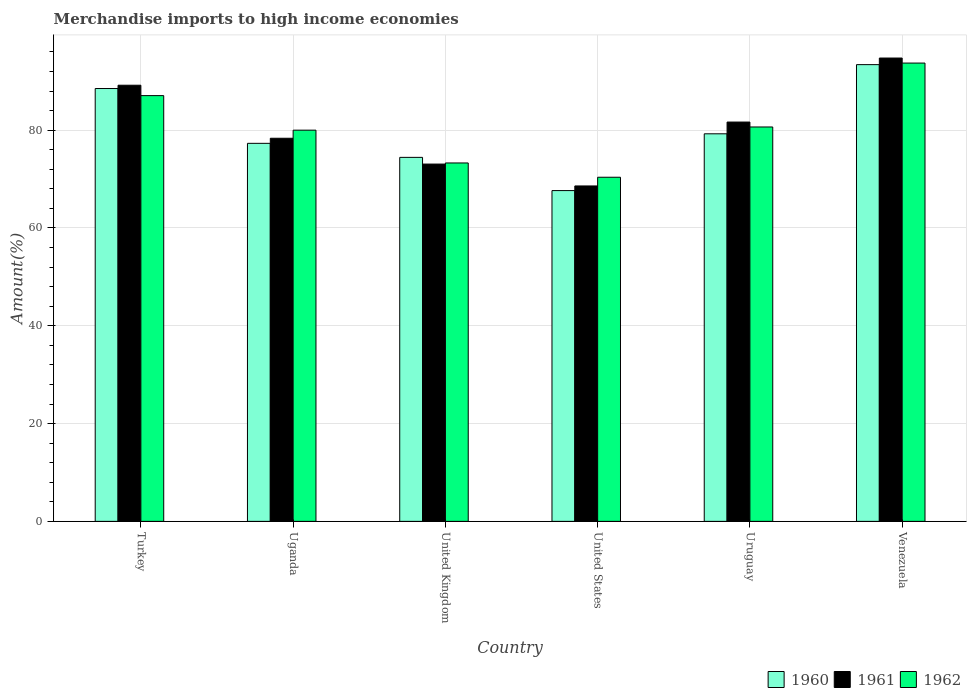Are the number of bars per tick equal to the number of legend labels?
Offer a terse response. Yes. How many bars are there on the 3rd tick from the right?
Ensure brevity in your answer.  3. What is the label of the 6th group of bars from the left?
Offer a terse response. Venezuela. In how many cases, is the number of bars for a given country not equal to the number of legend labels?
Make the answer very short. 0. What is the percentage of amount earned from merchandise imports in 1961 in United States?
Your response must be concise. 68.59. Across all countries, what is the maximum percentage of amount earned from merchandise imports in 1962?
Provide a short and direct response. 93.72. Across all countries, what is the minimum percentage of amount earned from merchandise imports in 1961?
Offer a very short reply. 68.59. In which country was the percentage of amount earned from merchandise imports in 1960 maximum?
Provide a succinct answer. Venezuela. In which country was the percentage of amount earned from merchandise imports in 1961 minimum?
Your response must be concise. United States. What is the total percentage of amount earned from merchandise imports in 1962 in the graph?
Keep it short and to the point. 485.11. What is the difference between the percentage of amount earned from merchandise imports in 1962 in United States and that in Venezuela?
Give a very brief answer. -23.35. What is the difference between the percentage of amount earned from merchandise imports in 1962 in Venezuela and the percentage of amount earned from merchandise imports in 1961 in Uganda?
Give a very brief answer. 15.38. What is the average percentage of amount earned from merchandise imports in 1962 per country?
Offer a terse response. 80.85. What is the difference between the percentage of amount earned from merchandise imports of/in 1961 and percentage of amount earned from merchandise imports of/in 1962 in Uganda?
Your answer should be compact. -1.65. In how many countries, is the percentage of amount earned from merchandise imports in 1960 greater than 88 %?
Your answer should be very brief. 2. What is the ratio of the percentage of amount earned from merchandise imports in 1961 in Turkey to that in United States?
Provide a short and direct response. 1.3. Is the percentage of amount earned from merchandise imports in 1961 in Turkey less than that in United States?
Provide a succinct answer. No. What is the difference between the highest and the second highest percentage of amount earned from merchandise imports in 1962?
Ensure brevity in your answer.  -13.07. What is the difference between the highest and the lowest percentage of amount earned from merchandise imports in 1962?
Ensure brevity in your answer.  23.35. Are all the bars in the graph horizontal?
Offer a very short reply. No. How many countries are there in the graph?
Your answer should be compact. 6. Are the values on the major ticks of Y-axis written in scientific E-notation?
Ensure brevity in your answer.  No. Does the graph contain grids?
Your answer should be compact. Yes. Where does the legend appear in the graph?
Your answer should be very brief. Bottom right. What is the title of the graph?
Offer a very short reply. Merchandise imports to high income economies. Does "2010" appear as one of the legend labels in the graph?
Give a very brief answer. No. What is the label or title of the X-axis?
Your answer should be compact. Country. What is the label or title of the Y-axis?
Keep it short and to the point. Amount(%). What is the Amount(%) of 1960 in Turkey?
Offer a very short reply. 88.52. What is the Amount(%) in 1961 in Turkey?
Give a very brief answer. 89.19. What is the Amount(%) of 1962 in Turkey?
Keep it short and to the point. 87.07. What is the Amount(%) in 1960 in Uganda?
Your answer should be very brief. 77.31. What is the Amount(%) of 1961 in Uganda?
Provide a short and direct response. 78.35. What is the Amount(%) of 1960 in United Kingdom?
Offer a terse response. 74.44. What is the Amount(%) of 1961 in United Kingdom?
Your answer should be very brief. 73.07. What is the Amount(%) of 1962 in United Kingdom?
Your answer should be compact. 73.3. What is the Amount(%) of 1960 in United States?
Provide a short and direct response. 67.65. What is the Amount(%) in 1961 in United States?
Provide a succinct answer. 68.59. What is the Amount(%) of 1962 in United States?
Your answer should be very brief. 70.37. What is the Amount(%) in 1960 in Uruguay?
Offer a terse response. 79.26. What is the Amount(%) in 1961 in Uruguay?
Provide a succinct answer. 81.66. What is the Amount(%) in 1962 in Uruguay?
Make the answer very short. 80.65. What is the Amount(%) of 1960 in Venezuela?
Keep it short and to the point. 93.4. What is the Amount(%) in 1961 in Venezuela?
Provide a short and direct response. 94.75. What is the Amount(%) in 1962 in Venezuela?
Your answer should be compact. 93.72. Across all countries, what is the maximum Amount(%) in 1960?
Offer a very short reply. 93.4. Across all countries, what is the maximum Amount(%) in 1961?
Offer a terse response. 94.75. Across all countries, what is the maximum Amount(%) of 1962?
Offer a terse response. 93.72. Across all countries, what is the minimum Amount(%) of 1960?
Make the answer very short. 67.65. Across all countries, what is the minimum Amount(%) of 1961?
Provide a succinct answer. 68.59. Across all countries, what is the minimum Amount(%) of 1962?
Make the answer very short. 70.37. What is the total Amount(%) of 1960 in the graph?
Offer a terse response. 480.57. What is the total Amount(%) in 1961 in the graph?
Provide a short and direct response. 485.61. What is the total Amount(%) in 1962 in the graph?
Keep it short and to the point. 485.11. What is the difference between the Amount(%) of 1960 in Turkey and that in Uganda?
Ensure brevity in your answer.  11.21. What is the difference between the Amount(%) of 1961 in Turkey and that in Uganda?
Ensure brevity in your answer.  10.84. What is the difference between the Amount(%) of 1962 in Turkey and that in Uganda?
Your answer should be compact. 7.07. What is the difference between the Amount(%) in 1960 in Turkey and that in United Kingdom?
Provide a succinct answer. 14.08. What is the difference between the Amount(%) of 1961 in Turkey and that in United Kingdom?
Make the answer very short. 16.12. What is the difference between the Amount(%) in 1962 in Turkey and that in United Kingdom?
Make the answer very short. 13.77. What is the difference between the Amount(%) of 1960 in Turkey and that in United States?
Your response must be concise. 20.87. What is the difference between the Amount(%) in 1961 in Turkey and that in United States?
Give a very brief answer. 20.6. What is the difference between the Amount(%) of 1962 in Turkey and that in United States?
Ensure brevity in your answer.  16.69. What is the difference between the Amount(%) of 1960 in Turkey and that in Uruguay?
Offer a terse response. 9.26. What is the difference between the Amount(%) in 1961 in Turkey and that in Uruguay?
Offer a very short reply. 7.53. What is the difference between the Amount(%) of 1962 in Turkey and that in Uruguay?
Provide a succinct answer. 6.41. What is the difference between the Amount(%) of 1960 in Turkey and that in Venezuela?
Keep it short and to the point. -4.89. What is the difference between the Amount(%) in 1961 in Turkey and that in Venezuela?
Ensure brevity in your answer.  -5.56. What is the difference between the Amount(%) of 1962 in Turkey and that in Venezuela?
Make the answer very short. -6.66. What is the difference between the Amount(%) of 1960 in Uganda and that in United Kingdom?
Offer a terse response. 2.87. What is the difference between the Amount(%) of 1961 in Uganda and that in United Kingdom?
Ensure brevity in your answer.  5.28. What is the difference between the Amount(%) in 1962 in Uganda and that in United Kingdom?
Make the answer very short. 6.7. What is the difference between the Amount(%) in 1960 in Uganda and that in United States?
Your response must be concise. 9.66. What is the difference between the Amount(%) in 1961 in Uganda and that in United States?
Ensure brevity in your answer.  9.75. What is the difference between the Amount(%) of 1962 in Uganda and that in United States?
Your answer should be very brief. 9.63. What is the difference between the Amount(%) of 1960 in Uganda and that in Uruguay?
Give a very brief answer. -1.95. What is the difference between the Amount(%) in 1961 in Uganda and that in Uruguay?
Your response must be concise. -3.32. What is the difference between the Amount(%) in 1962 in Uganda and that in Uruguay?
Provide a succinct answer. -0.65. What is the difference between the Amount(%) of 1960 in Uganda and that in Venezuela?
Your answer should be very brief. -16.1. What is the difference between the Amount(%) of 1961 in Uganda and that in Venezuela?
Keep it short and to the point. -16.41. What is the difference between the Amount(%) of 1962 in Uganda and that in Venezuela?
Your response must be concise. -13.72. What is the difference between the Amount(%) in 1960 in United Kingdom and that in United States?
Provide a succinct answer. 6.79. What is the difference between the Amount(%) of 1961 in United Kingdom and that in United States?
Offer a very short reply. 4.48. What is the difference between the Amount(%) of 1962 in United Kingdom and that in United States?
Ensure brevity in your answer.  2.92. What is the difference between the Amount(%) of 1960 in United Kingdom and that in Uruguay?
Offer a terse response. -4.82. What is the difference between the Amount(%) in 1961 in United Kingdom and that in Uruguay?
Your answer should be very brief. -8.59. What is the difference between the Amount(%) in 1962 in United Kingdom and that in Uruguay?
Keep it short and to the point. -7.36. What is the difference between the Amount(%) of 1960 in United Kingdom and that in Venezuela?
Your answer should be compact. -18.97. What is the difference between the Amount(%) in 1961 in United Kingdom and that in Venezuela?
Provide a short and direct response. -21.68. What is the difference between the Amount(%) of 1962 in United Kingdom and that in Venezuela?
Offer a very short reply. -20.43. What is the difference between the Amount(%) of 1960 in United States and that in Uruguay?
Your answer should be very brief. -11.61. What is the difference between the Amount(%) in 1961 in United States and that in Uruguay?
Make the answer very short. -13.07. What is the difference between the Amount(%) in 1962 in United States and that in Uruguay?
Offer a terse response. -10.28. What is the difference between the Amount(%) in 1960 in United States and that in Venezuela?
Keep it short and to the point. -25.76. What is the difference between the Amount(%) of 1961 in United States and that in Venezuela?
Make the answer very short. -26.16. What is the difference between the Amount(%) in 1962 in United States and that in Venezuela?
Offer a very short reply. -23.35. What is the difference between the Amount(%) of 1960 in Uruguay and that in Venezuela?
Keep it short and to the point. -14.15. What is the difference between the Amount(%) of 1961 in Uruguay and that in Venezuela?
Offer a terse response. -13.09. What is the difference between the Amount(%) in 1962 in Uruguay and that in Venezuela?
Your answer should be very brief. -13.07. What is the difference between the Amount(%) in 1960 in Turkey and the Amount(%) in 1961 in Uganda?
Offer a terse response. 10.17. What is the difference between the Amount(%) in 1960 in Turkey and the Amount(%) in 1962 in Uganda?
Ensure brevity in your answer.  8.52. What is the difference between the Amount(%) in 1961 in Turkey and the Amount(%) in 1962 in Uganda?
Keep it short and to the point. 9.19. What is the difference between the Amount(%) in 1960 in Turkey and the Amount(%) in 1961 in United Kingdom?
Make the answer very short. 15.45. What is the difference between the Amount(%) in 1960 in Turkey and the Amount(%) in 1962 in United Kingdom?
Provide a short and direct response. 15.22. What is the difference between the Amount(%) in 1961 in Turkey and the Amount(%) in 1962 in United Kingdom?
Your answer should be compact. 15.89. What is the difference between the Amount(%) of 1960 in Turkey and the Amount(%) of 1961 in United States?
Ensure brevity in your answer.  19.93. What is the difference between the Amount(%) of 1960 in Turkey and the Amount(%) of 1962 in United States?
Give a very brief answer. 18.14. What is the difference between the Amount(%) in 1961 in Turkey and the Amount(%) in 1962 in United States?
Make the answer very short. 18.82. What is the difference between the Amount(%) in 1960 in Turkey and the Amount(%) in 1961 in Uruguay?
Offer a terse response. 6.86. What is the difference between the Amount(%) in 1960 in Turkey and the Amount(%) in 1962 in Uruguay?
Your answer should be compact. 7.87. What is the difference between the Amount(%) of 1961 in Turkey and the Amount(%) of 1962 in Uruguay?
Keep it short and to the point. 8.54. What is the difference between the Amount(%) in 1960 in Turkey and the Amount(%) in 1961 in Venezuela?
Offer a very short reply. -6.23. What is the difference between the Amount(%) of 1960 in Turkey and the Amount(%) of 1962 in Venezuela?
Give a very brief answer. -5.2. What is the difference between the Amount(%) in 1961 in Turkey and the Amount(%) in 1962 in Venezuela?
Make the answer very short. -4.53. What is the difference between the Amount(%) in 1960 in Uganda and the Amount(%) in 1961 in United Kingdom?
Offer a terse response. 4.24. What is the difference between the Amount(%) of 1960 in Uganda and the Amount(%) of 1962 in United Kingdom?
Ensure brevity in your answer.  4.01. What is the difference between the Amount(%) in 1961 in Uganda and the Amount(%) in 1962 in United Kingdom?
Offer a very short reply. 5.05. What is the difference between the Amount(%) of 1960 in Uganda and the Amount(%) of 1961 in United States?
Make the answer very short. 8.71. What is the difference between the Amount(%) of 1960 in Uganda and the Amount(%) of 1962 in United States?
Offer a terse response. 6.93. What is the difference between the Amount(%) in 1961 in Uganda and the Amount(%) in 1962 in United States?
Your answer should be very brief. 7.97. What is the difference between the Amount(%) in 1960 in Uganda and the Amount(%) in 1961 in Uruguay?
Offer a very short reply. -4.35. What is the difference between the Amount(%) of 1960 in Uganda and the Amount(%) of 1962 in Uruguay?
Your answer should be compact. -3.35. What is the difference between the Amount(%) in 1961 in Uganda and the Amount(%) in 1962 in Uruguay?
Offer a very short reply. -2.31. What is the difference between the Amount(%) of 1960 in Uganda and the Amount(%) of 1961 in Venezuela?
Make the answer very short. -17.44. What is the difference between the Amount(%) in 1960 in Uganda and the Amount(%) in 1962 in Venezuela?
Make the answer very short. -16.42. What is the difference between the Amount(%) of 1961 in Uganda and the Amount(%) of 1962 in Venezuela?
Offer a very short reply. -15.38. What is the difference between the Amount(%) in 1960 in United Kingdom and the Amount(%) in 1961 in United States?
Give a very brief answer. 5.84. What is the difference between the Amount(%) of 1960 in United Kingdom and the Amount(%) of 1962 in United States?
Keep it short and to the point. 4.06. What is the difference between the Amount(%) in 1961 in United Kingdom and the Amount(%) in 1962 in United States?
Offer a terse response. 2.7. What is the difference between the Amount(%) in 1960 in United Kingdom and the Amount(%) in 1961 in Uruguay?
Keep it short and to the point. -7.22. What is the difference between the Amount(%) in 1960 in United Kingdom and the Amount(%) in 1962 in Uruguay?
Your answer should be compact. -6.21. What is the difference between the Amount(%) of 1961 in United Kingdom and the Amount(%) of 1962 in Uruguay?
Give a very brief answer. -7.58. What is the difference between the Amount(%) of 1960 in United Kingdom and the Amount(%) of 1961 in Venezuela?
Your response must be concise. -20.31. What is the difference between the Amount(%) in 1960 in United Kingdom and the Amount(%) in 1962 in Venezuela?
Your response must be concise. -19.28. What is the difference between the Amount(%) of 1961 in United Kingdom and the Amount(%) of 1962 in Venezuela?
Your answer should be very brief. -20.65. What is the difference between the Amount(%) in 1960 in United States and the Amount(%) in 1961 in Uruguay?
Make the answer very short. -14.01. What is the difference between the Amount(%) of 1960 in United States and the Amount(%) of 1962 in Uruguay?
Your answer should be very brief. -13.01. What is the difference between the Amount(%) in 1961 in United States and the Amount(%) in 1962 in Uruguay?
Provide a short and direct response. -12.06. What is the difference between the Amount(%) of 1960 in United States and the Amount(%) of 1961 in Venezuela?
Your answer should be very brief. -27.1. What is the difference between the Amount(%) of 1960 in United States and the Amount(%) of 1962 in Venezuela?
Make the answer very short. -26.08. What is the difference between the Amount(%) of 1961 in United States and the Amount(%) of 1962 in Venezuela?
Your response must be concise. -25.13. What is the difference between the Amount(%) of 1960 in Uruguay and the Amount(%) of 1961 in Venezuela?
Give a very brief answer. -15.5. What is the difference between the Amount(%) of 1960 in Uruguay and the Amount(%) of 1962 in Venezuela?
Offer a very short reply. -14.47. What is the difference between the Amount(%) of 1961 in Uruguay and the Amount(%) of 1962 in Venezuela?
Provide a short and direct response. -12.06. What is the average Amount(%) in 1960 per country?
Offer a terse response. 80.09. What is the average Amount(%) of 1961 per country?
Keep it short and to the point. 80.94. What is the average Amount(%) of 1962 per country?
Offer a very short reply. 80.85. What is the difference between the Amount(%) in 1960 and Amount(%) in 1961 in Turkey?
Provide a succinct answer. -0.67. What is the difference between the Amount(%) of 1960 and Amount(%) of 1962 in Turkey?
Provide a succinct answer. 1.45. What is the difference between the Amount(%) of 1961 and Amount(%) of 1962 in Turkey?
Offer a terse response. 2.12. What is the difference between the Amount(%) in 1960 and Amount(%) in 1961 in Uganda?
Keep it short and to the point. -1.04. What is the difference between the Amount(%) of 1960 and Amount(%) of 1962 in Uganda?
Provide a short and direct response. -2.69. What is the difference between the Amount(%) in 1961 and Amount(%) in 1962 in Uganda?
Provide a succinct answer. -1.65. What is the difference between the Amount(%) of 1960 and Amount(%) of 1961 in United Kingdom?
Provide a succinct answer. 1.37. What is the difference between the Amount(%) of 1960 and Amount(%) of 1962 in United Kingdom?
Give a very brief answer. 1.14. What is the difference between the Amount(%) of 1961 and Amount(%) of 1962 in United Kingdom?
Your answer should be very brief. -0.23. What is the difference between the Amount(%) of 1960 and Amount(%) of 1961 in United States?
Keep it short and to the point. -0.95. What is the difference between the Amount(%) of 1960 and Amount(%) of 1962 in United States?
Your answer should be very brief. -2.73. What is the difference between the Amount(%) in 1961 and Amount(%) in 1962 in United States?
Offer a terse response. -1.78. What is the difference between the Amount(%) of 1960 and Amount(%) of 1961 in Uruguay?
Give a very brief answer. -2.41. What is the difference between the Amount(%) in 1960 and Amount(%) in 1962 in Uruguay?
Keep it short and to the point. -1.4. What is the difference between the Amount(%) in 1961 and Amount(%) in 1962 in Uruguay?
Ensure brevity in your answer.  1.01. What is the difference between the Amount(%) of 1960 and Amount(%) of 1961 in Venezuela?
Your answer should be compact. -1.35. What is the difference between the Amount(%) in 1960 and Amount(%) in 1962 in Venezuela?
Your response must be concise. -0.32. What is the ratio of the Amount(%) of 1960 in Turkey to that in Uganda?
Ensure brevity in your answer.  1.15. What is the ratio of the Amount(%) in 1961 in Turkey to that in Uganda?
Provide a short and direct response. 1.14. What is the ratio of the Amount(%) in 1962 in Turkey to that in Uganda?
Offer a terse response. 1.09. What is the ratio of the Amount(%) of 1960 in Turkey to that in United Kingdom?
Offer a terse response. 1.19. What is the ratio of the Amount(%) of 1961 in Turkey to that in United Kingdom?
Provide a short and direct response. 1.22. What is the ratio of the Amount(%) of 1962 in Turkey to that in United Kingdom?
Make the answer very short. 1.19. What is the ratio of the Amount(%) in 1960 in Turkey to that in United States?
Provide a succinct answer. 1.31. What is the ratio of the Amount(%) in 1961 in Turkey to that in United States?
Offer a very short reply. 1.3. What is the ratio of the Amount(%) in 1962 in Turkey to that in United States?
Offer a very short reply. 1.24. What is the ratio of the Amount(%) of 1960 in Turkey to that in Uruguay?
Provide a short and direct response. 1.12. What is the ratio of the Amount(%) of 1961 in Turkey to that in Uruguay?
Your answer should be very brief. 1.09. What is the ratio of the Amount(%) in 1962 in Turkey to that in Uruguay?
Offer a very short reply. 1.08. What is the ratio of the Amount(%) of 1960 in Turkey to that in Venezuela?
Ensure brevity in your answer.  0.95. What is the ratio of the Amount(%) of 1961 in Turkey to that in Venezuela?
Give a very brief answer. 0.94. What is the ratio of the Amount(%) of 1962 in Turkey to that in Venezuela?
Provide a succinct answer. 0.93. What is the ratio of the Amount(%) in 1961 in Uganda to that in United Kingdom?
Provide a short and direct response. 1.07. What is the ratio of the Amount(%) of 1962 in Uganda to that in United Kingdom?
Your answer should be very brief. 1.09. What is the ratio of the Amount(%) in 1960 in Uganda to that in United States?
Offer a terse response. 1.14. What is the ratio of the Amount(%) of 1961 in Uganda to that in United States?
Offer a very short reply. 1.14. What is the ratio of the Amount(%) of 1962 in Uganda to that in United States?
Offer a very short reply. 1.14. What is the ratio of the Amount(%) in 1960 in Uganda to that in Uruguay?
Ensure brevity in your answer.  0.98. What is the ratio of the Amount(%) of 1961 in Uganda to that in Uruguay?
Your answer should be compact. 0.96. What is the ratio of the Amount(%) of 1960 in Uganda to that in Venezuela?
Provide a short and direct response. 0.83. What is the ratio of the Amount(%) of 1961 in Uganda to that in Venezuela?
Your answer should be very brief. 0.83. What is the ratio of the Amount(%) in 1962 in Uganda to that in Venezuela?
Offer a terse response. 0.85. What is the ratio of the Amount(%) of 1960 in United Kingdom to that in United States?
Offer a very short reply. 1.1. What is the ratio of the Amount(%) of 1961 in United Kingdom to that in United States?
Your response must be concise. 1.07. What is the ratio of the Amount(%) in 1962 in United Kingdom to that in United States?
Your response must be concise. 1.04. What is the ratio of the Amount(%) in 1960 in United Kingdom to that in Uruguay?
Ensure brevity in your answer.  0.94. What is the ratio of the Amount(%) in 1961 in United Kingdom to that in Uruguay?
Your answer should be compact. 0.89. What is the ratio of the Amount(%) of 1962 in United Kingdom to that in Uruguay?
Offer a very short reply. 0.91. What is the ratio of the Amount(%) in 1960 in United Kingdom to that in Venezuela?
Provide a short and direct response. 0.8. What is the ratio of the Amount(%) of 1961 in United Kingdom to that in Venezuela?
Ensure brevity in your answer.  0.77. What is the ratio of the Amount(%) of 1962 in United Kingdom to that in Venezuela?
Make the answer very short. 0.78. What is the ratio of the Amount(%) in 1960 in United States to that in Uruguay?
Provide a succinct answer. 0.85. What is the ratio of the Amount(%) of 1961 in United States to that in Uruguay?
Offer a terse response. 0.84. What is the ratio of the Amount(%) in 1962 in United States to that in Uruguay?
Ensure brevity in your answer.  0.87. What is the ratio of the Amount(%) of 1960 in United States to that in Venezuela?
Provide a short and direct response. 0.72. What is the ratio of the Amount(%) in 1961 in United States to that in Venezuela?
Give a very brief answer. 0.72. What is the ratio of the Amount(%) of 1962 in United States to that in Venezuela?
Make the answer very short. 0.75. What is the ratio of the Amount(%) in 1960 in Uruguay to that in Venezuela?
Provide a short and direct response. 0.85. What is the ratio of the Amount(%) of 1961 in Uruguay to that in Venezuela?
Your response must be concise. 0.86. What is the ratio of the Amount(%) of 1962 in Uruguay to that in Venezuela?
Ensure brevity in your answer.  0.86. What is the difference between the highest and the second highest Amount(%) of 1960?
Your answer should be very brief. 4.89. What is the difference between the highest and the second highest Amount(%) of 1961?
Make the answer very short. 5.56. What is the difference between the highest and the second highest Amount(%) of 1962?
Offer a terse response. 6.66. What is the difference between the highest and the lowest Amount(%) of 1960?
Ensure brevity in your answer.  25.76. What is the difference between the highest and the lowest Amount(%) in 1961?
Your answer should be compact. 26.16. What is the difference between the highest and the lowest Amount(%) in 1962?
Give a very brief answer. 23.35. 